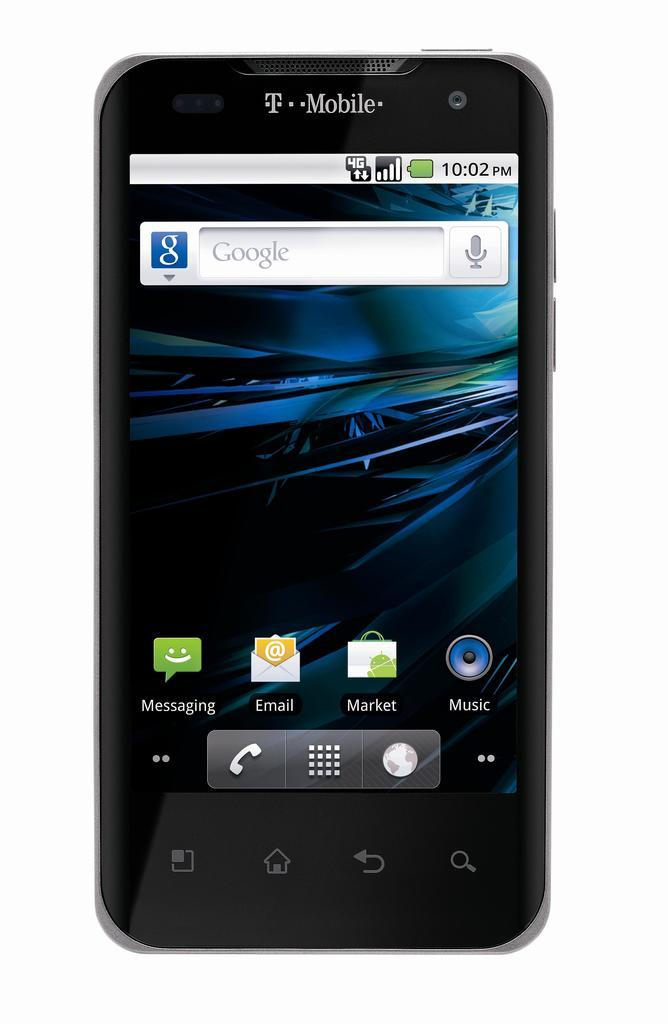Provide a one-sentence caption for the provided image. An old T-mobile phone is sitting on the home screen. 